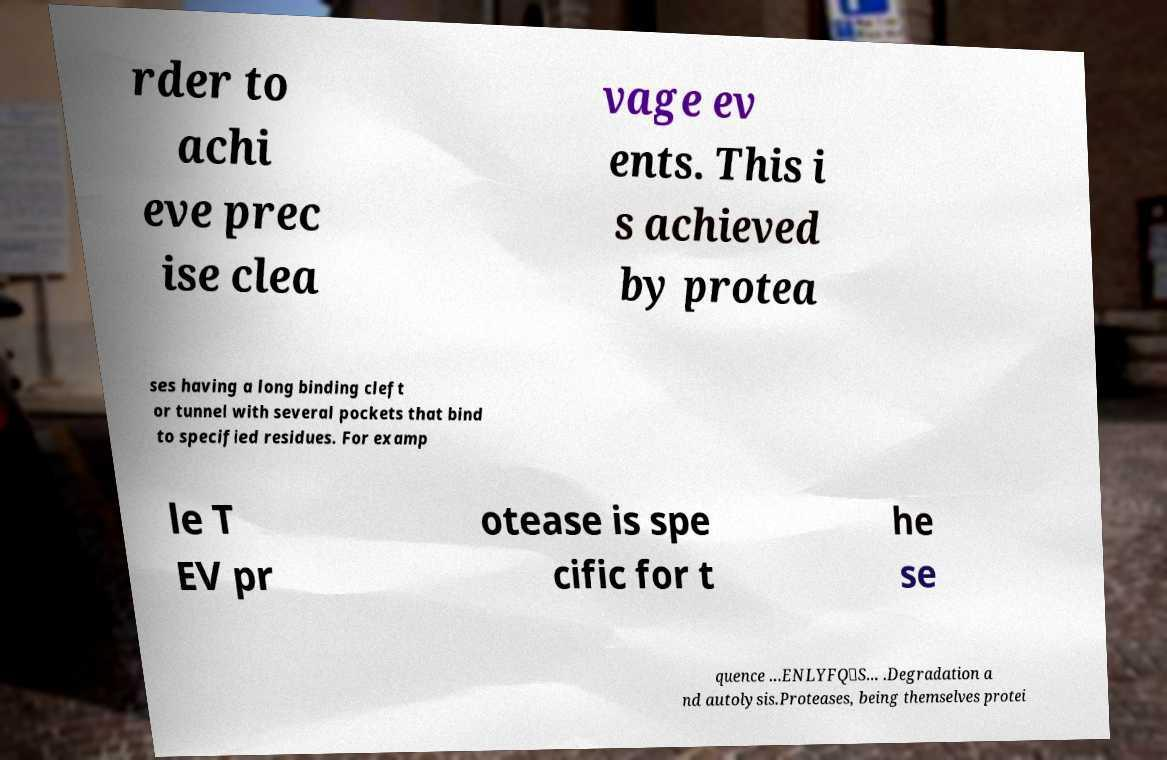Can you accurately transcribe the text from the provided image for me? rder to achi eve prec ise clea vage ev ents. This i s achieved by protea ses having a long binding cleft or tunnel with several pockets that bind to specified residues. For examp le T EV pr otease is spe cific for t he se quence ...ENLYFQ\S... .Degradation a nd autolysis.Proteases, being themselves protei 